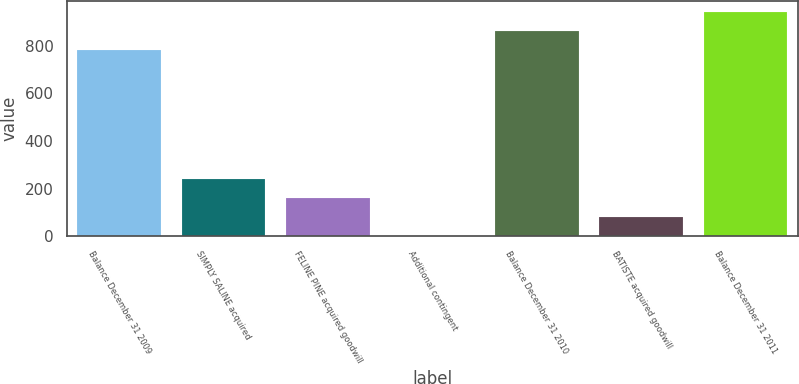Convert chart. <chart><loc_0><loc_0><loc_500><loc_500><bar_chart><fcel>Balance December 31 2009<fcel>SIMPLY SALINE acquired<fcel>FELINE PINE acquired goodwill<fcel>Additional contingent<fcel>Balance December 31 2010<fcel>BATISTE acquired goodwill<fcel>Balance December 31 2011<nl><fcel>781.4<fcel>240.65<fcel>160.6<fcel>0.5<fcel>861.45<fcel>80.55<fcel>941.5<nl></chart> 